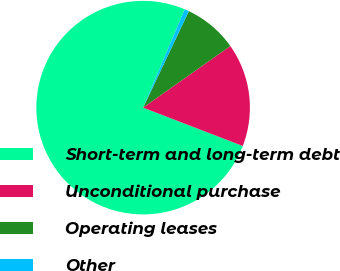Convert chart to OTSL. <chart><loc_0><loc_0><loc_500><loc_500><pie_chart><fcel>Short-term and long-term debt<fcel>Unconditional purchase<fcel>Operating leases<fcel>Other<nl><fcel>75.53%<fcel>15.64%<fcel>8.16%<fcel>0.67%<nl></chart> 